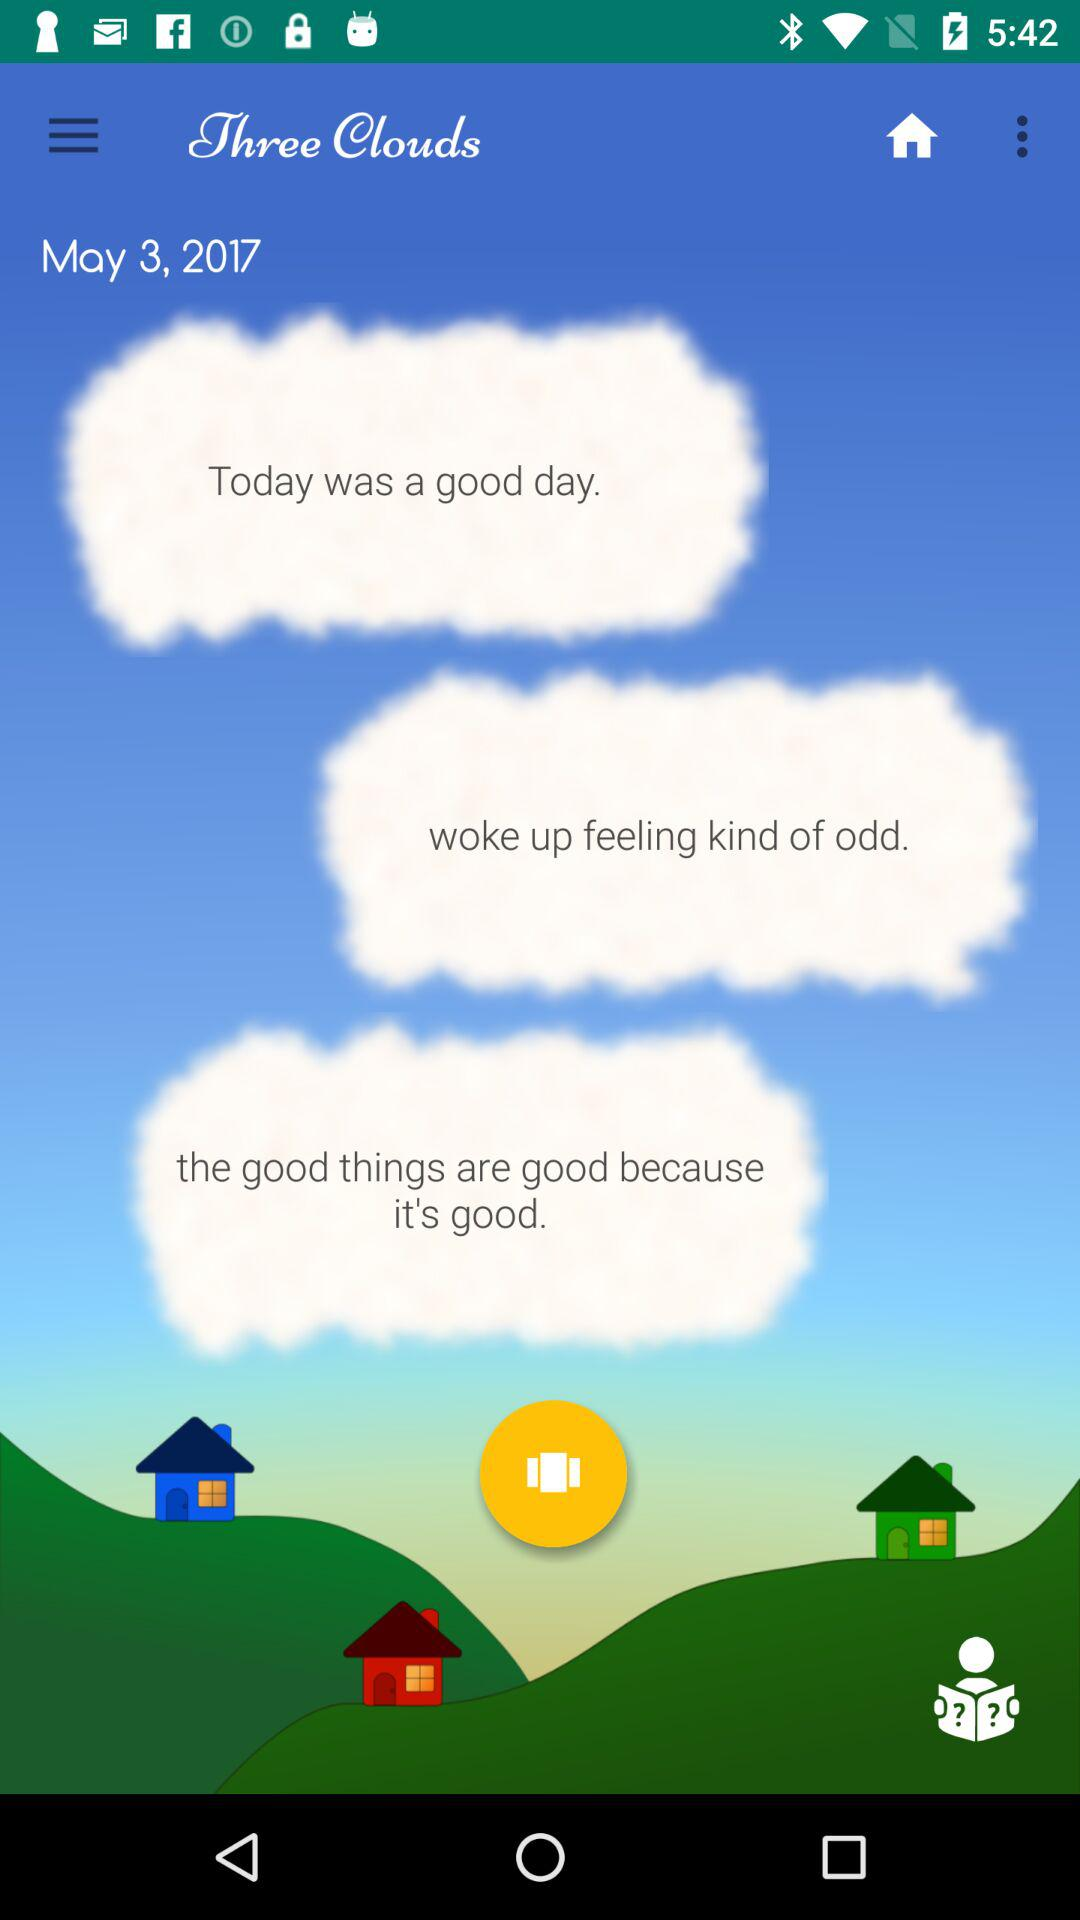What is the mentioned date? The mentioned date is May 3, 2017. 